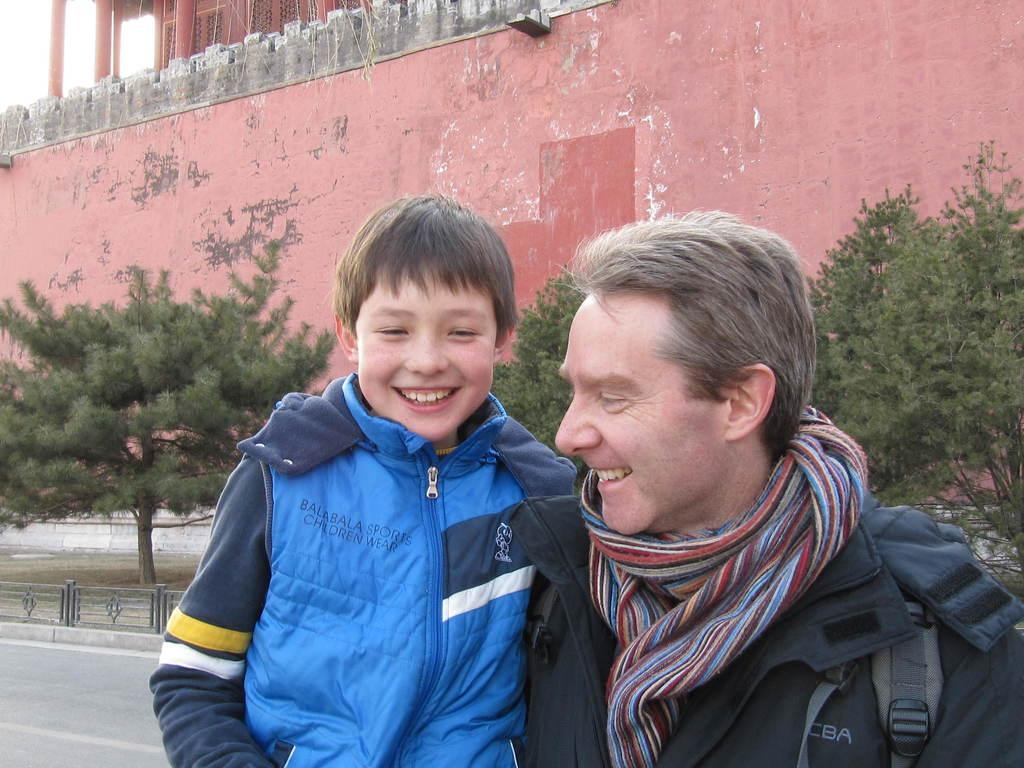Who is present in the image? There is a man and a boy in the image. What are the expressions of the man and the boy? Both the man and the boy are smiling. What can be seen in the background of the image? There are iron grills, a road, at least one building, trees, and the sky visible in the background of the image. What type of chain is being used to stop the car in the image? There is no car or chain present in the image; it features a man and a boy smiling, along with various background elements. 